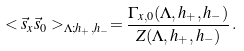<formula> <loc_0><loc_0><loc_500><loc_500>< \vec { s } _ { x } \vec { s } _ { 0 } > _ { \Lambda ; h _ { + } , h _ { - } } = \frac { \Gamma _ { x , 0 } ( \Lambda , h _ { + } , h _ { - } ) } { Z ( \Lambda , h _ { + } , h _ { - } ) } \, .</formula> 